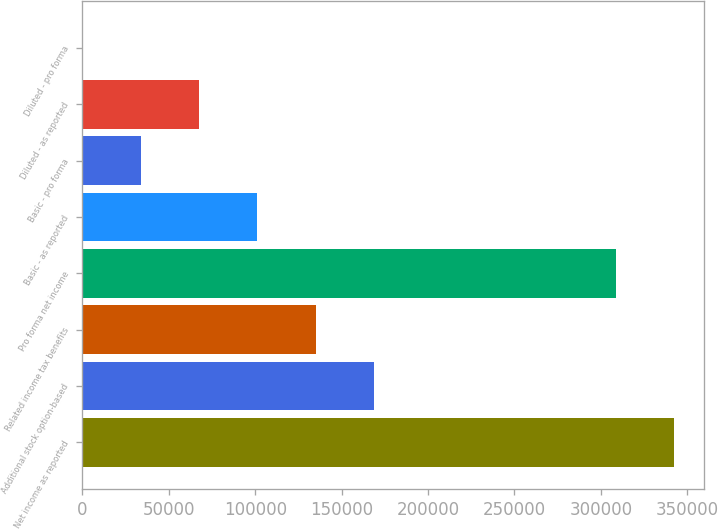<chart> <loc_0><loc_0><loc_500><loc_500><bar_chart><fcel>Net income as reported<fcel>Additional stock option-based<fcel>Related income tax benefits<fcel>Pro forma net income<fcel>Basic - as reported<fcel>Basic - pro forma<fcel>Diluted - as reported<fcel>Diluted - pro forma<nl><fcel>342522<fcel>168631<fcel>134905<fcel>308796<fcel>101180<fcel>33728.1<fcel>67453.9<fcel>2.31<nl></chart> 